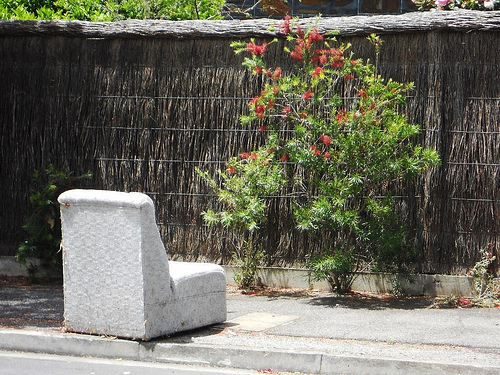<image>
Is the sofa on the fence? No. The sofa is not positioned on the fence. They may be near each other, but the sofa is not supported by or resting on top of the fence. 